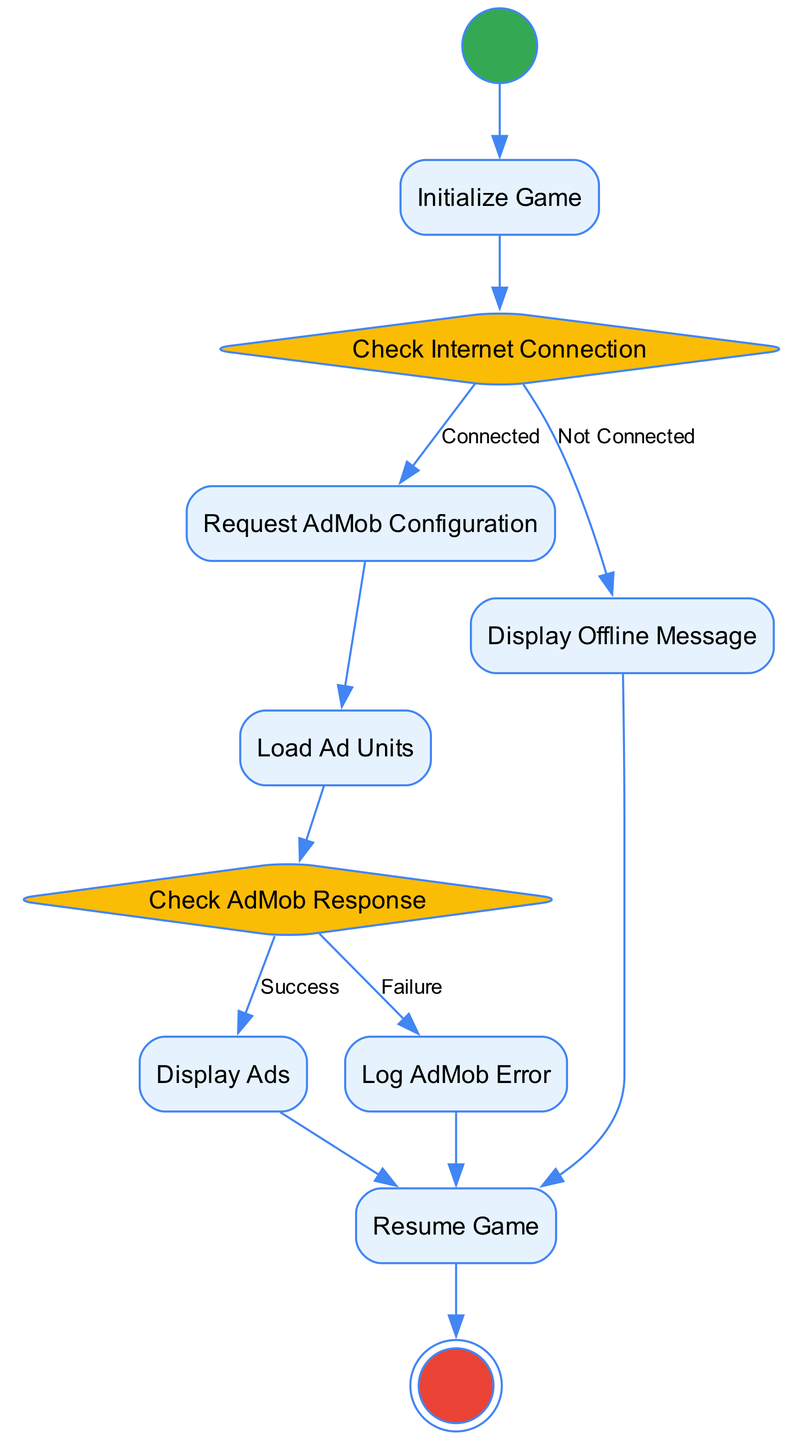What is the initial activity in the diagram? The diagram starts with the "Start" activity, indicated as the initial node. This node is represented by a circle shape, which is a common visual representation for initial states in activity diagrams.
Answer: Start How many decision nodes are present in the diagram? There are two decision nodes in the diagram: "Check Internet Connection" and "Check AdMob Response". Each decision node has branches leading to different outcomes based on conditions.
Answer: 2 What happens if the internet connection is not connected? If the connection is not established, the flow proceeds to the "Display Offline Message" activity as indicated by the outgoing transition from the "Check Internet Connection" decision node.
Answer: Display Offline Message What is the next activity after successfully checking the AdMob response? Upon a successful response from AdMob, the diagram indicates that the next activity is "Display Ads", as per the outgoing transition from the "Check AdMob Response" decision node labeled "Success".
Answer: Display Ads What is the final activity in the flow? The diagram concludes with the "End" activity, which is marked as the final node in the flow, typically represented by a double circle.
Answer: End What is indicated if the AdMob response fails? In the case of a failure in the AdMob response, the flow directs to the "Log AdMob Error" activity based on the decision made at "Check AdMob Response" for the condition labeled "Failure".
Answer: Log AdMob Error Explain the flow if the internet is connected? If the internet is connected, after the "Check Internet Connection" decision, the flow moves to "Request AdMob Configuration", then to "Load Ad Units", and subsequently to "Check AdMob Response", leading to either "Display Ads" or "Log AdMob Error" depending on the response's success or failure.
Answer: Request AdMob Configuration -> Load Ad Units -> Check AdMob Response -> Display Ads / Log AdMob Error How many actions are included in the diagram? The actions included in the diagram are: "Initialize Game," "Request AdMob Configuration," "Load Ad Units," "Display Offline Message," "Display Ads," "Log AdMob Error," and "Resume Game." Counting these, there are a total of seven actions.
Answer: 7 